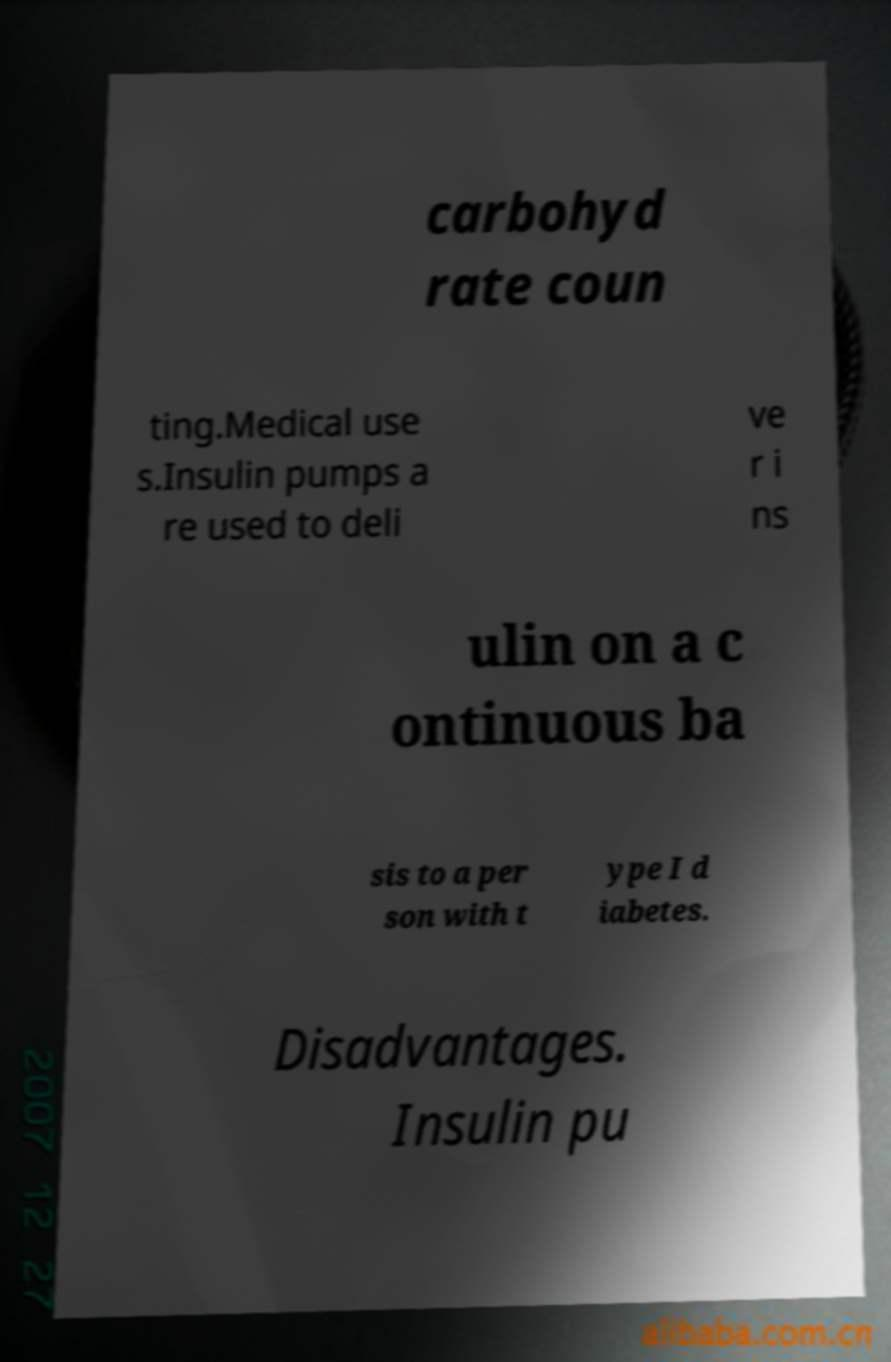What messages or text are displayed in this image? I need them in a readable, typed format. carbohyd rate coun ting.Medical use s.Insulin pumps a re used to deli ve r i ns ulin on a c ontinuous ba sis to a per son with t ype I d iabetes. Disadvantages. Insulin pu 